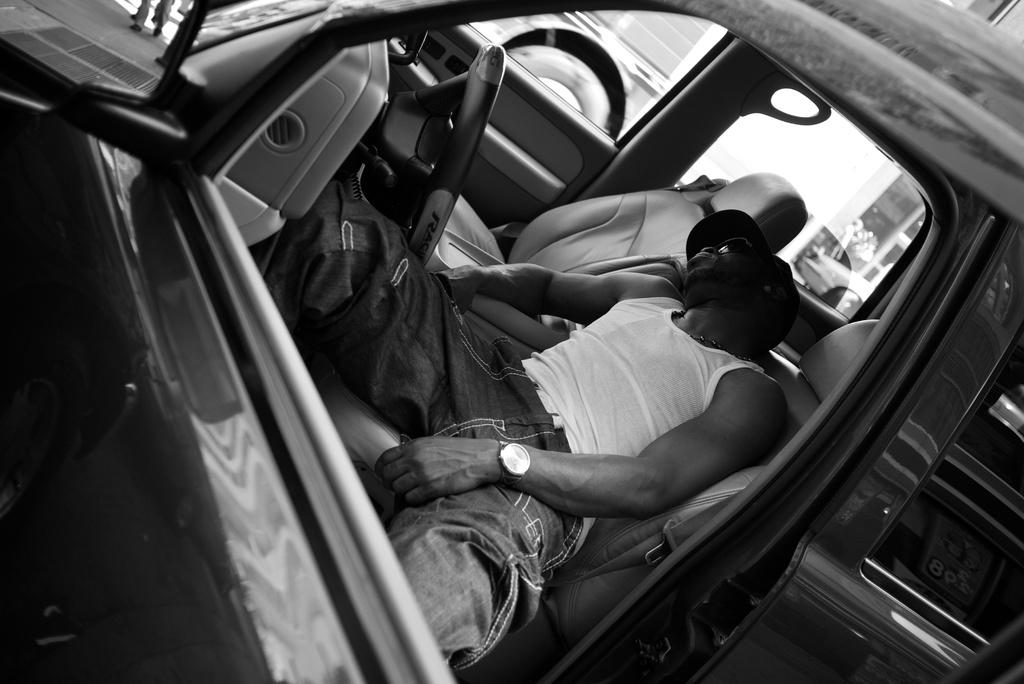What is the color scheme of the image? The image is black and white. Where was the image taken? The image was taken inside a car. What is the person in the image doing? There is a person sleeping in the car. What color is the shirt the person is wearing? The person is wearing a white shirt. What accessory is the person wearing on their hand? The person has a watch on their hand. What type of headwear is the person wearing? The person is wearing a cap. What type of voyage is the person planning in the image? There is no indication of a voyage or any travel plans in the image; the person is simply sleeping in the car. What thought is the person having while sleeping in the image? It is impossible to determine the person's thoughts while they are sleeping in the image. 